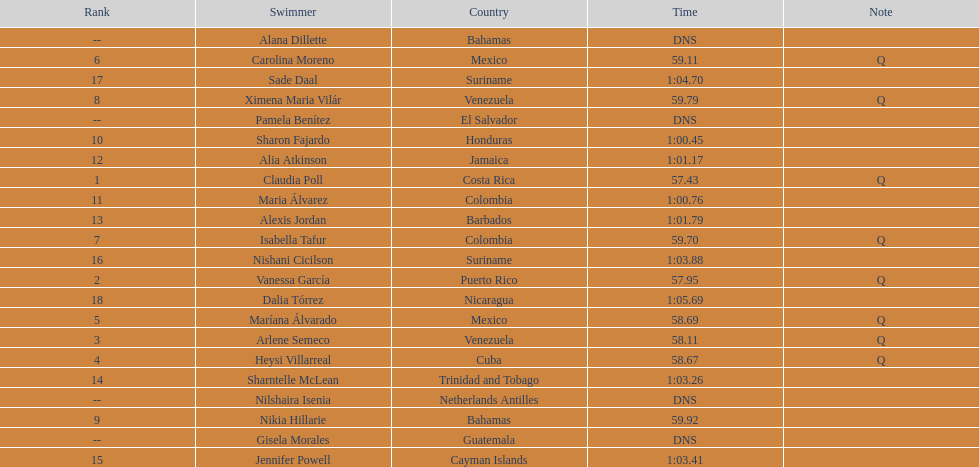How many swimmers did not swim? 4. 